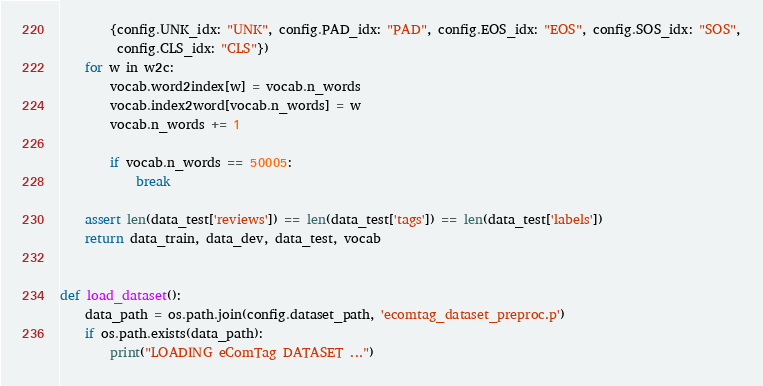<code> <loc_0><loc_0><loc_500><loc_500><_Python_>        {config.UNK_idx: "UNK", config.PAD_idx: "PAD", config.EOS_idx: "EOS", config.SOS_idx: "SOS",
         config.CLS_idx: "CLS"})
    for w in w2c:
        vocab.word2index[w] = vocab.n_words
        vocab.index2word[vocab.n_words] = w
        vocab.n_words += 1

        if vocab.n_words == 50005:
            break

    assert len(data_test['reviews']) == len(data_test['tags']) == len(data_test['labels'])
    return data_train, data_dev, data_test, vocab


def load_dataset():
    data_path = os.path.join(config.dataset_path, 'ecomtag_dataset_preproc.p')
    if os.path.exists(data_path):
        print("LOADING eComTag DATASET ...")</code> 